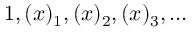Convert formula to latex. <formula><loc_0><loc_0><loc_500><loc_500>1 , ( x ) _ { 1 } , ( x ) _ { 2 } , ( x ) _ { 3 } , \dots</formula> 